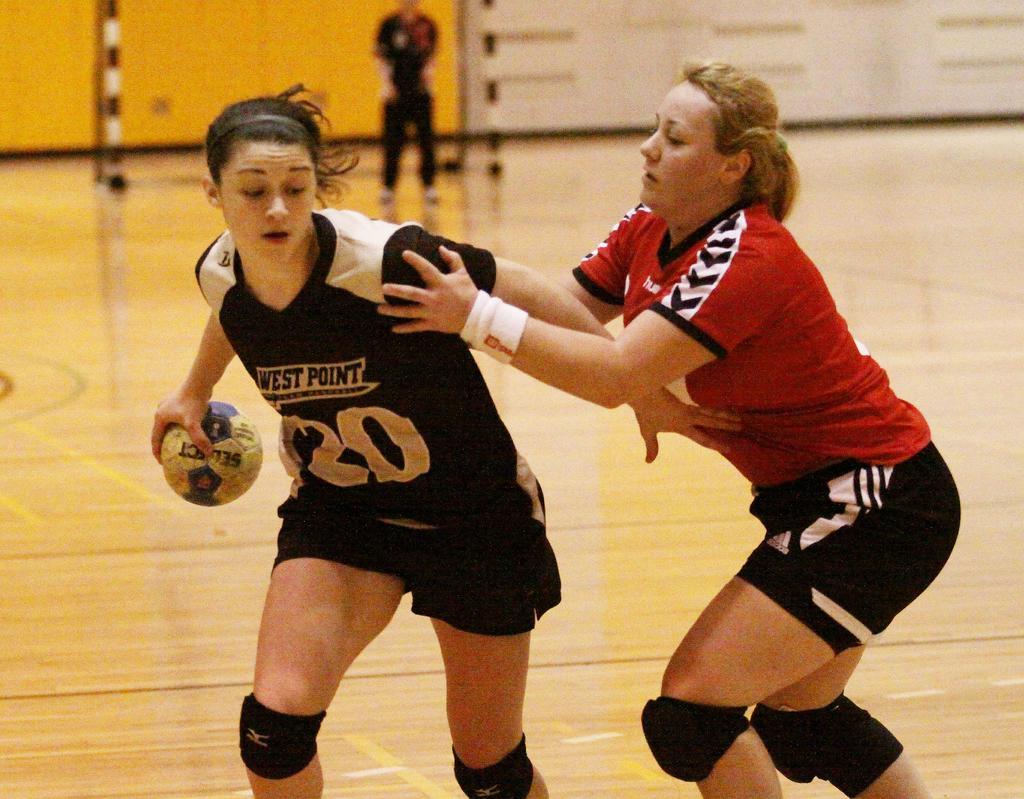Describe this image in one or two sentences. In this picture we can see two women and a woman holding a ball with her hand. In the background we can see a person standing on the ground, wall and some objects. 